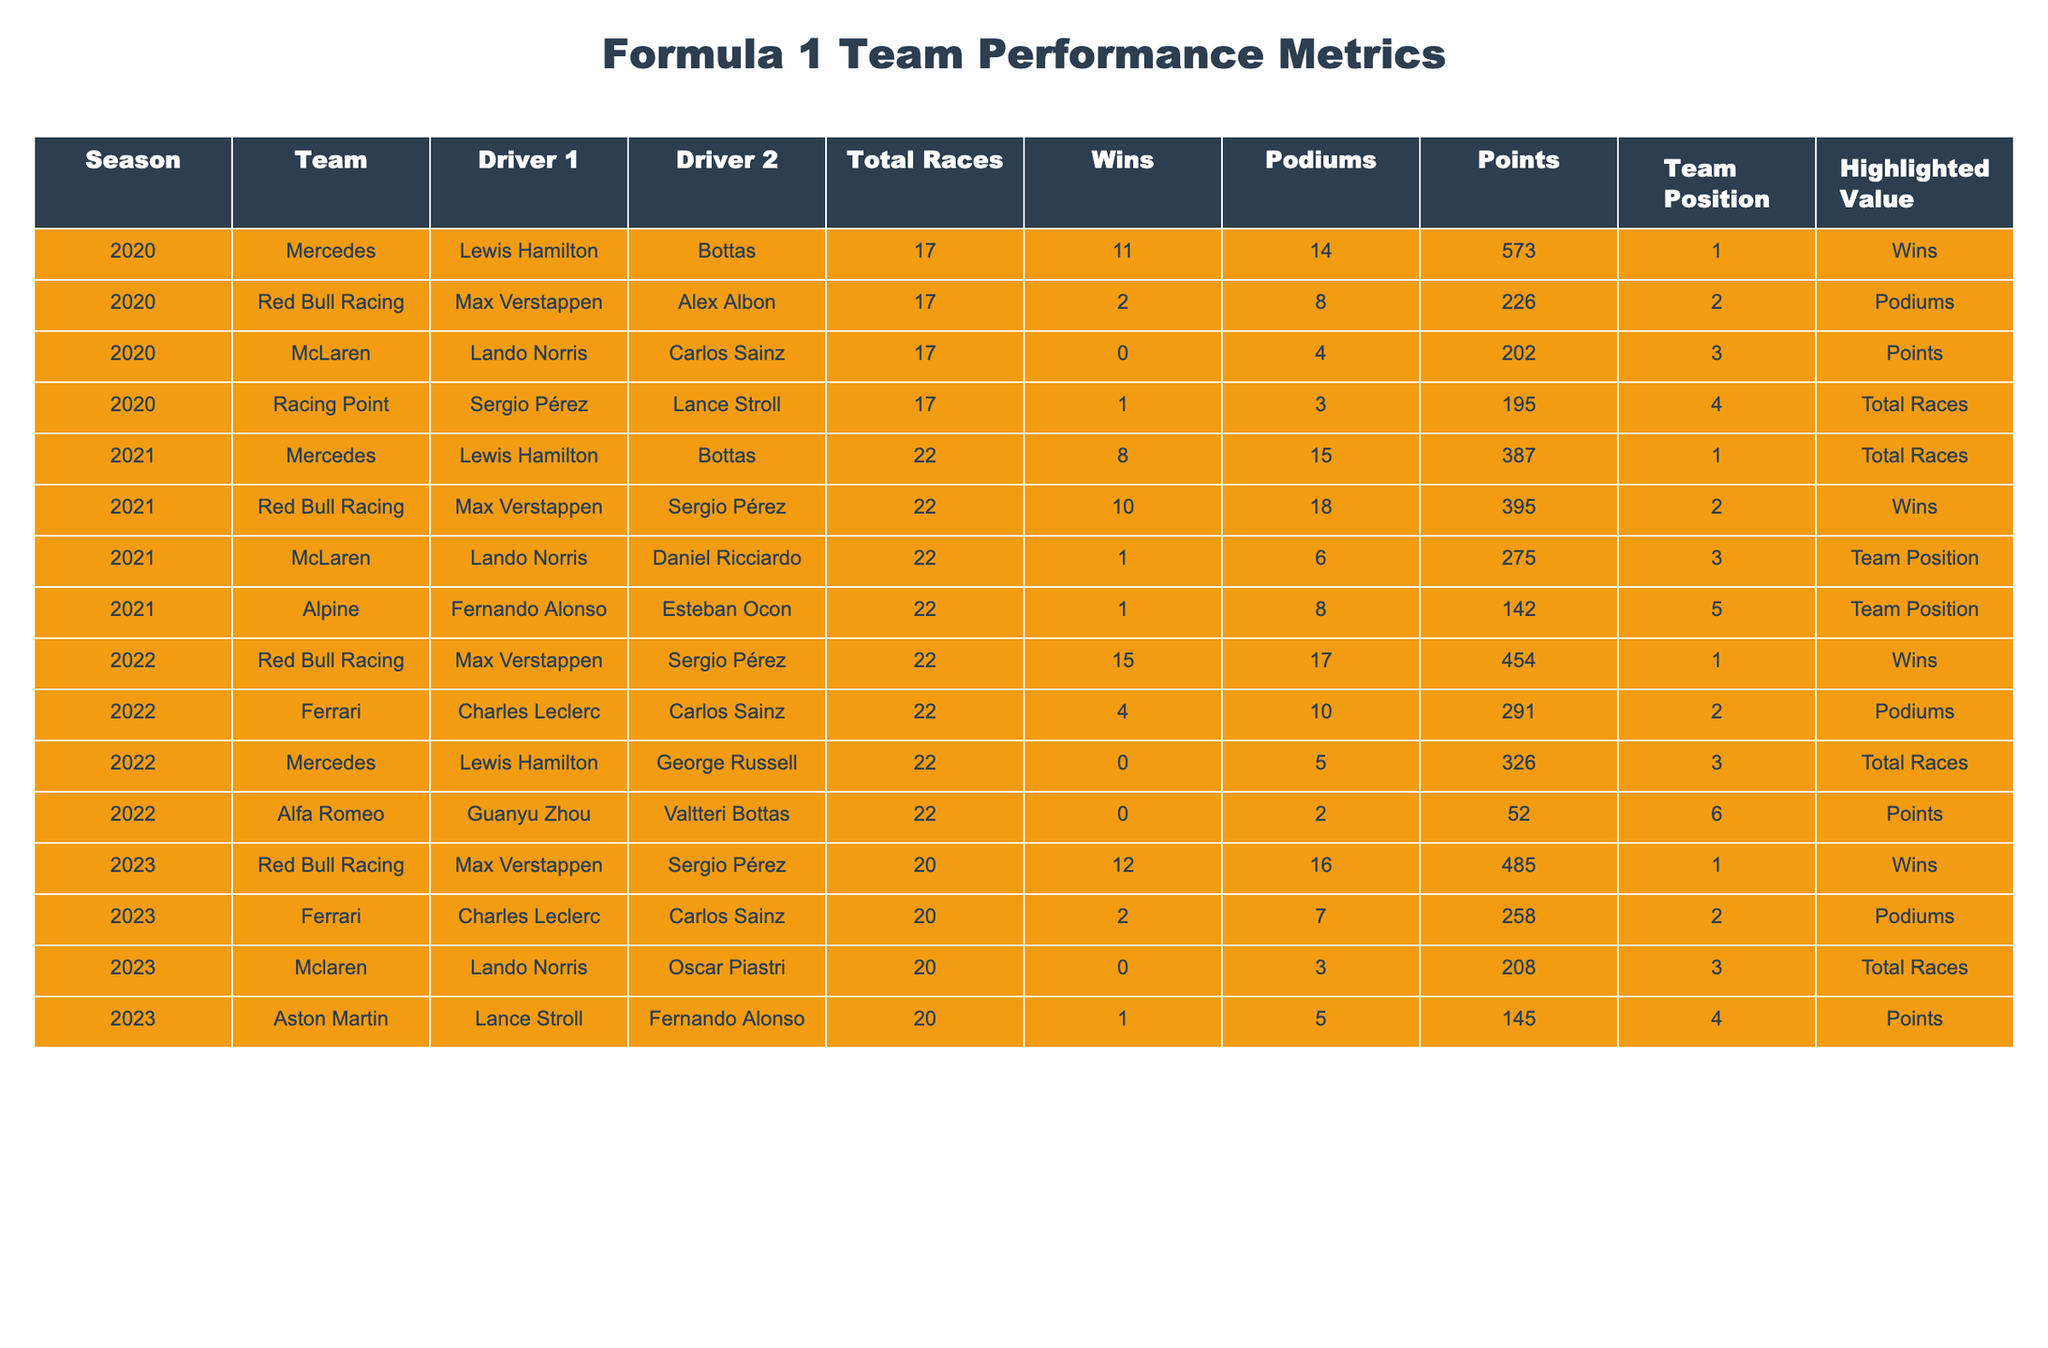What team had the most wins in 2022? Red Bull Racing had 15 wins in 2022, which is the highest among all teams that season.
Answer: Red Bull Racing Which season did McLaren have the highest total of points? McLaren had 275 points in the 2021 season, which is the highest total for them in the data provided.
Answer: 2021 How many podiums did Ferrari achieve in 2023? Ferrari achieved 7 podiums in the 2023 season, as indicated in the table.
Answer: 7 Did Mercedes achieve any wins in the 2022 season? Mercedes did not achieve any wins in 2022; their total wins that season is listed as 0.
Answer: No What is the total number of races across all seasons reported in 2020? Adding the races from each team in 2020: Mercedes (17) + Red Bull Racing (17) + McLaren (17) + Racing Point (17) = 68 total races.
Answer: 68 Which driver secured the most points in 2021? Max Verstappen scored 395 points in 2021, which is the highest among all drivers in that year.
Answer: Max Verstappen How many wins did Mercedes have in 2021 compared to 2020? Mercedes had 8 wins in 2021 and 11 wins in 2020, showing a decrease of 3 wins from 2020 to 2021.
Answer: 3 Which teams have the same total races for the 2020 season, and how many races did they have? All teams participated in 17 races in the 2020 season, as seen in the table.
Answer: 17 What is the average number of podiums for Red Bull Racing across the reported seasons? Red Bull Racing had 8 (2020) + 18 (2021) + 17 (2022) + 16 (2023) = 59 podiums. There are 4 seasons, so 59/4 = 14.75, which rounds to 15.
Answer: 15 Which team placed first in the team standings for 2023? Red Bull Racing secured the first position in the team standings for the 2023 season.
Answer: Red Bull Racing How does the total points for Mercedes in 2021 compare to the total points for McLaren in 2022? Mercedes had 387 points in 2021 and McLaren had 202 points in 2022, showing that Mercedes scored 185 points more.
Answer: 185 more 